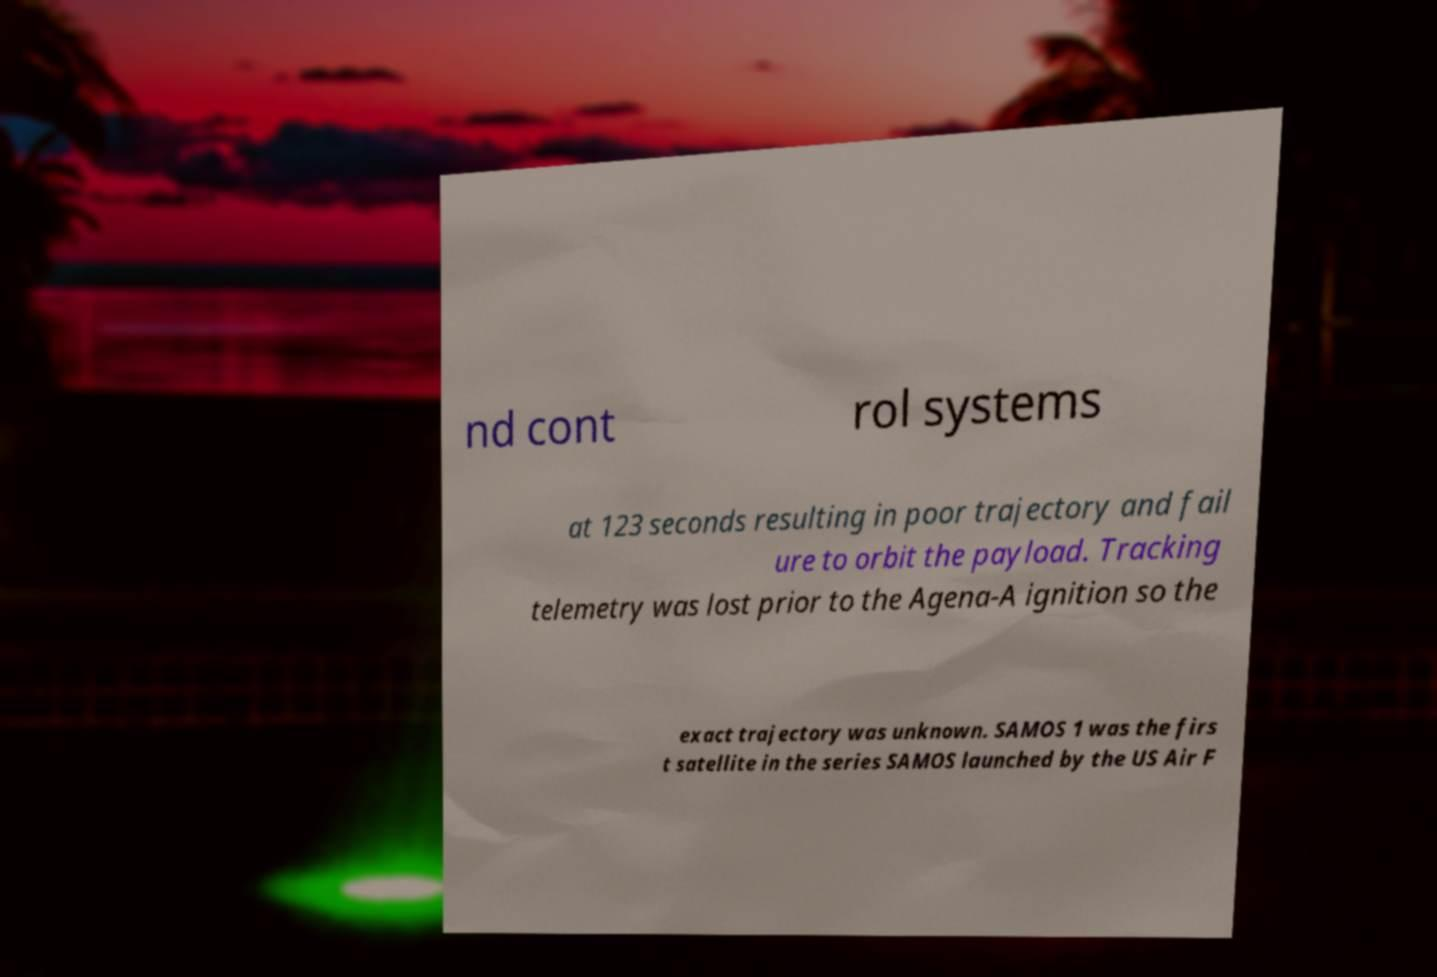Please identify and transcribe the text found in this image. nd cont rol systems at 123 seconds resulting in poor trajectory and fail ure to orbit the payload. Tracking telemetry was lost prior to the Agena-A ignition so the exact trajectory was unknown. SAMOS 1 was the firs t satellite in the series SAMOS launched by the US Air F 